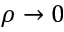Convert formula to latex. <formula><loc_0><loc_0><loc_500><loc_500>\rho \to 0</formula> 